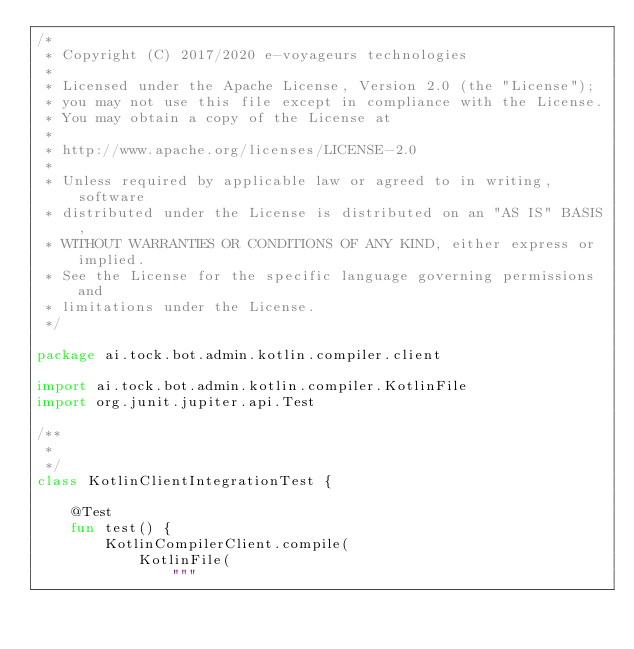Convert code to text. <code><loc_0><loc_0><loc_500><loc_500><_Kotlin_>/*
 * Copyright (C) 2017/2020 e-voyageurs technologies
 *
 * Licensed under the Apache License, Version 2.0 (the "License");
 * you may not use this file except in compliance with the License.
 * You may obtain a copy of the License at
 *
 * http://www.apache.org/licenses/LICENSE-2.0
 *
 * Unless required by applicable law or agreed to in writing, software
 * distributed under the License is distributed on an "AS IS" BASIS,
 * WITHOUT WARRANTIES OR CONDITIONS OF ANY KIND, either express or implied.
 * See the License for the specific language governing permissions and
 * limitations under the License.
 */

package ai.tock.bot.admin.kotlin.compiler.client

import ai.tock.bot.admin.kotlin.compiler.KotlinFile
import org.junit.jupiter.api.Test

/**
 *
 */
class KotlinClientIntegrationTest {

    @Test
    fun test() {
        KotlinCompilerClient.compile(
            KotlinFile(
                """</code> 